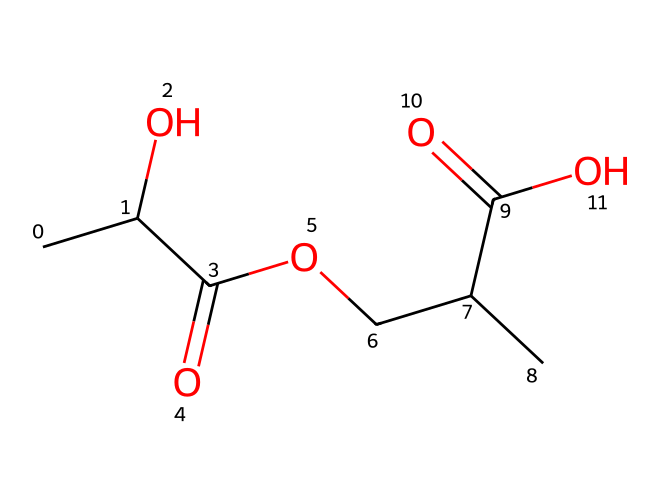How many carbon atoms are present in the molecule? By analyzing the SMILES representation, we can count the total number of carbon (C) atoms. The structure shows multiple "C" entries, each representing a carbon atom. Upon examination, we find that there are 8 carbon atoms in total.
Answer: 8 What type of polymer is represented by this chemical? The molecule contains sequences of lactic acid units, which are indicative of a biodegradable polymer commonly used in medical applications. This type of polymer is classified specifically as polylactic acid or PLA.
Answer: polylactic acid How many ester functional groups are present in the molecule? An ester functional group is identified by the presence of a carbonyl (C=O) adjacent to an oxygen atom (O) linked to an alkyl group. By examining the SMILES representation, we can identify two distinct occurrences of this functional group.
Answer: 2 What is the molecular weight of this compound? To determine the molecular weight, we add the atomic weights of all atoms present in the molecule as indicated by the SMILES. Based on typical atomic weights (C=12, H=1, O=16), the combined molecular weight calculates to approximately 174 grams per mole.
Answer: 174 What property makes this polymer suitable for surgical sutures? The key property that makes polylactic acid suitable for surgical sutures is its biodegradability, allowing it to be absorbed by the body over time without the need for removal. This characteristic ensures it supports healing while minimizing complications.
Answer: biodegradability What is the degree of polymerization if one repeating unit of lactic acid is considered? The degree of polymerization refers to the number of repeating units in the polymer chain. In this case, since it is based on lactic acid, and we assume a typical dimerization under industrial polymerization processes, the degree of polymerization for the simplest form is often 2.
Answer: 2 What influence does the arrangement of functional groups have on its properties? The arrangement of functional groups, such as hydroxyl (-OH) and carbonyls in the structure, influences solubility, thermal properties, and degradation rates of the polymer. These factors are crucial for biomedical applications, such as sutures which require specific performance characteristics during and after application.
Answer: influences solubility and degradation rates 